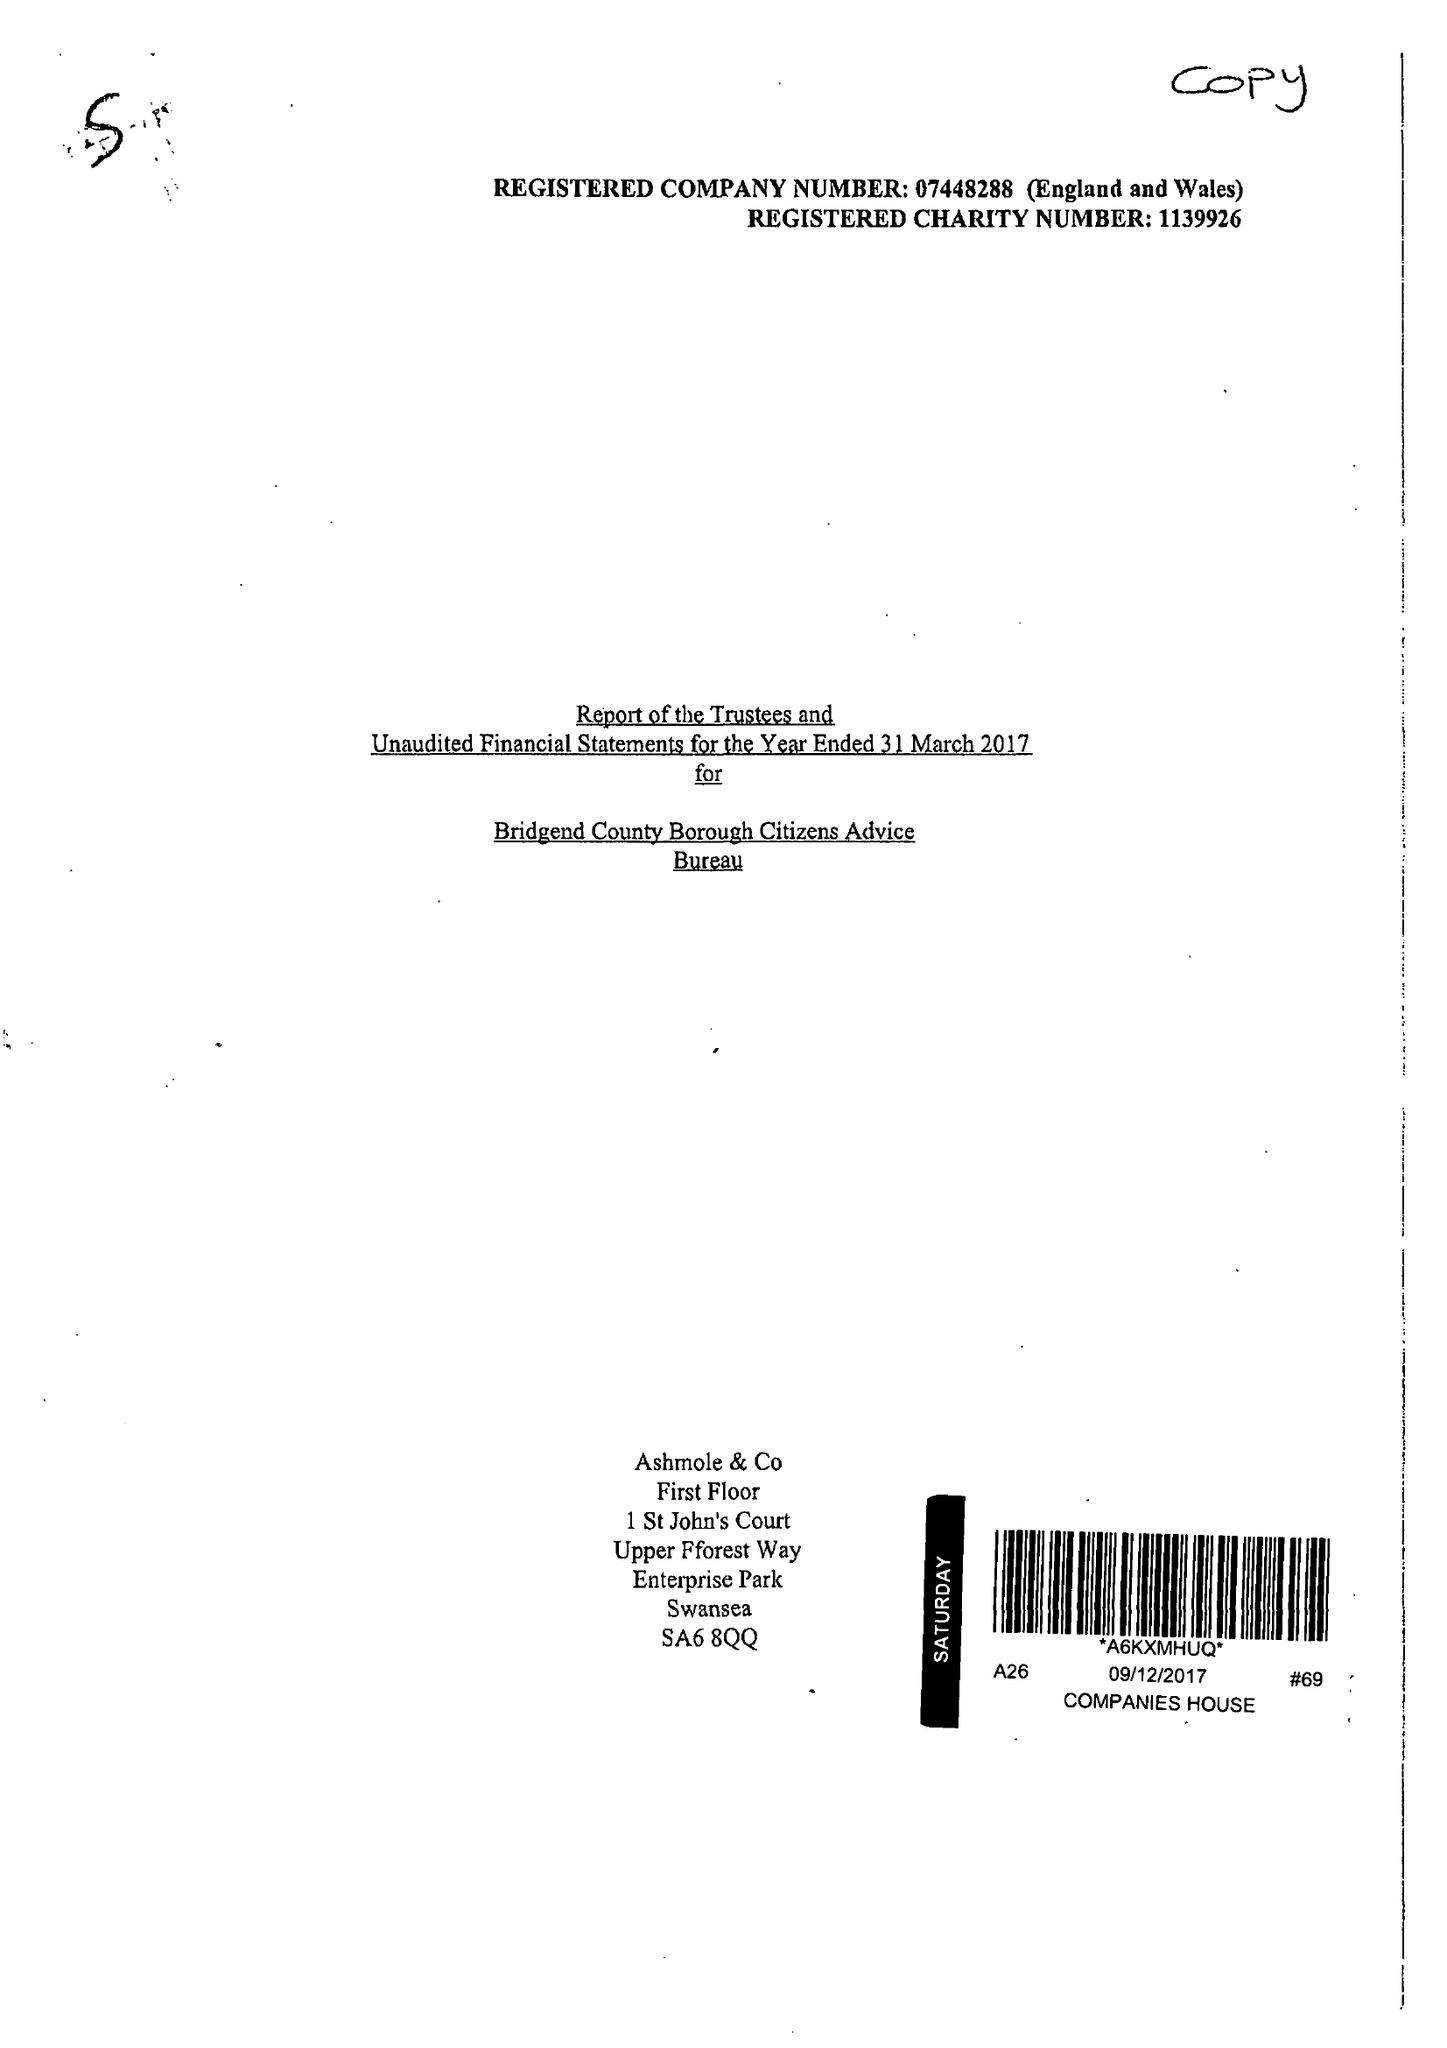What is the value for the address__post_town?
Answer the question using a single word or phrase. BRIDGEND 